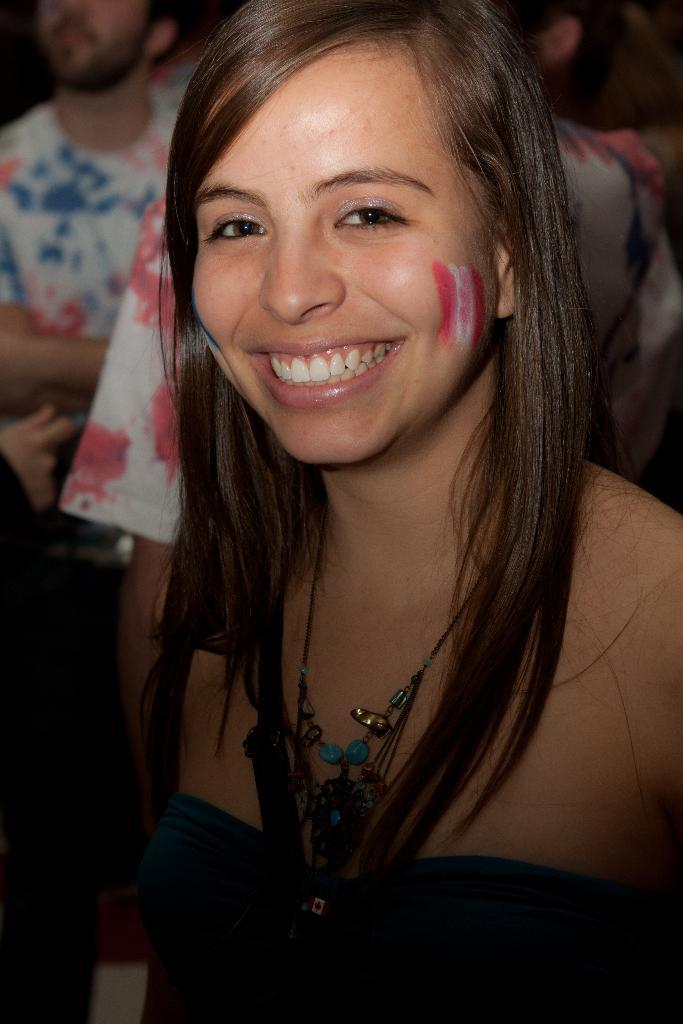Who is the main subject in the image? There is a woman in the image. Can you describe the people behind the woman? There are a few persons behind the woman in the image. What type of zinc is being used to create the scent in the image? There is no mention of zinc or scent in the image, so it cannot be determined from the image. 